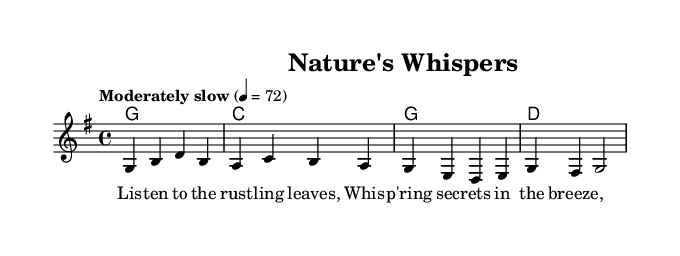What is the key signature of this music? The key signature is G major, which has one sharp (F#). This can be determined by examining the key indicated at the beginning of the score where it shows "g major".
Answer: G major What is the time signature of this music? The time signature is 4/4, meaning there are four beats in a measure and the quarter note receives one beat. This information is found in the time signature notation at the beginning of the score.
Answer: 4/4 What is the tempo marking? The tempo marking is "Moderately slow", indicating the speed of the piece. This is indicated at the beginning of the score where it states "Moderately slow" followed by a metronome marking of 4 = 72.
Answer: Moderately slow What is the melodic range of the piece? The melodic range is from G to B, which can be observed by looking at the highest and lowest notes in the melody section. The lowest note in the melody is G, and the highest note is B in the first measure.
Answer: G to B How many measures are in the score? There are four measures in the score, which can be counted by looking at the melody line and counting each vertical bar line that separates each measure.
Answer: 4 What are the lyrics for the first verse? The lyrics for the first verse are: "Listen to the rustling leaves, Whispering secrets in the breeze,". This can be found written under the melody line, showing the lyrics matched to the corresponding notes.
Answer: Listen to the rustling leaves, Whispering secrets in the breeze What kind of folk themes does this piece evoke? This piece evokes themes of nature and fortune-telling, as indicated by the title "Nature's Whispers" and the lyrics that reference leaves and secrets. These elements are common in folk music, which often draws on natural imagery and storytelling connected to omens and signs.
Answer: Nature and fortune-telling 